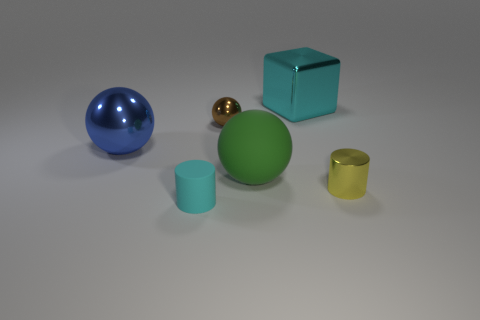What is the shape of the small object in front of the yellow metallic cylinder?
Offer a very short reply. Cylinder. What is the material of the other cylinder that is the same size as the cyan rubber cylinder?
Provide a short and direct response. Metal. How many objects are either big things that are left of the small cyan matte object or things that are behind the tiny cyan rubber thing?
Offer a very short reply. 5. There is a cube that is the same material as the blue ball; what is its size?
Keep it short and to the point. Large. What number of matte things are tiny cyan cylinders or large brown things?
Provide a short and direct response. 1. How big is the blue ball?
Ensure brevity in your answer.  Large. Is the matte cylinder the same size as the cyan metallic object?
Offer a very short reply. No. What is the cylinder right of the cyan rubber thing made of?
Make the answer very short. Metal. There is another blue object that is the same shape as the large matte thing; what material is it?
Offer a terse response. Metal. Is there a small cylinder in front of the metallic sphere on the right side of the blue ball?
Your answer should be compact. Yes. 